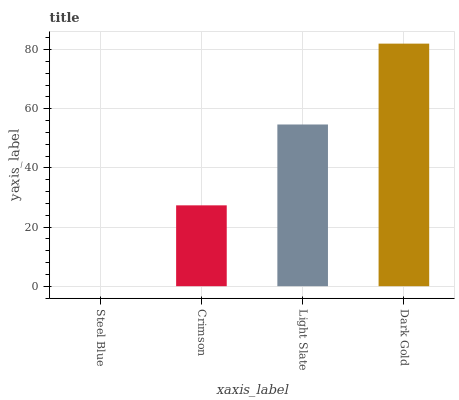Is Steel Blue the minimum?
Answer yes or no. Yes. Is Dark Gold the maximum?
Answer yes or no. Yes. Is Crimson the minimum?
Answer yes or no. No. Is Crimson the maximum?
Answer yes or no. No. Is Crimson greater than Steel Blue?
Answer yes or no. Yes. Is Steel Blue less than Crimson?
Answer yes or no. Yes. Is Steel Blue greater than Crimson?
Answer yes or no. No. Is Crimson less than Steel Blue?
Answer yes or no. No. Is Light Slate the high median?
Answer yes or no. Yes. Is Crimson the low median?
Answer yes or no. Yes. Is Dark Gold the high median?
Answer yes or no. No. Is Light Slate the low median?
Answer yes or no. No. 